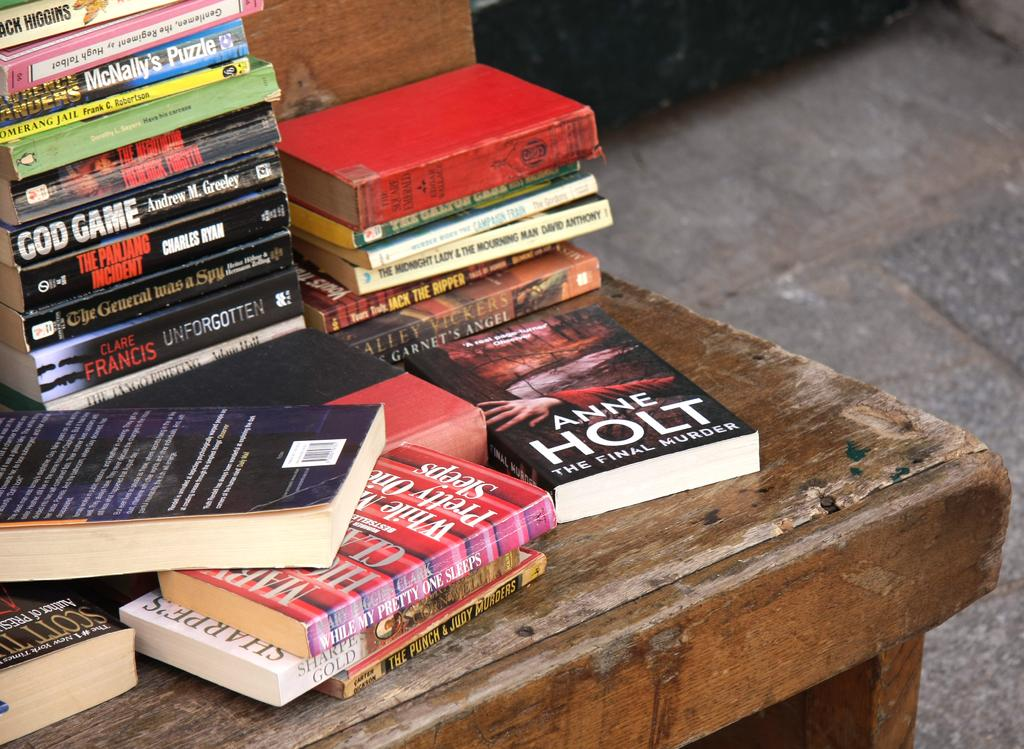<image>
Render a clear and concise summary of the photo. A pile of books, one on the far right is by Anne Holt. 